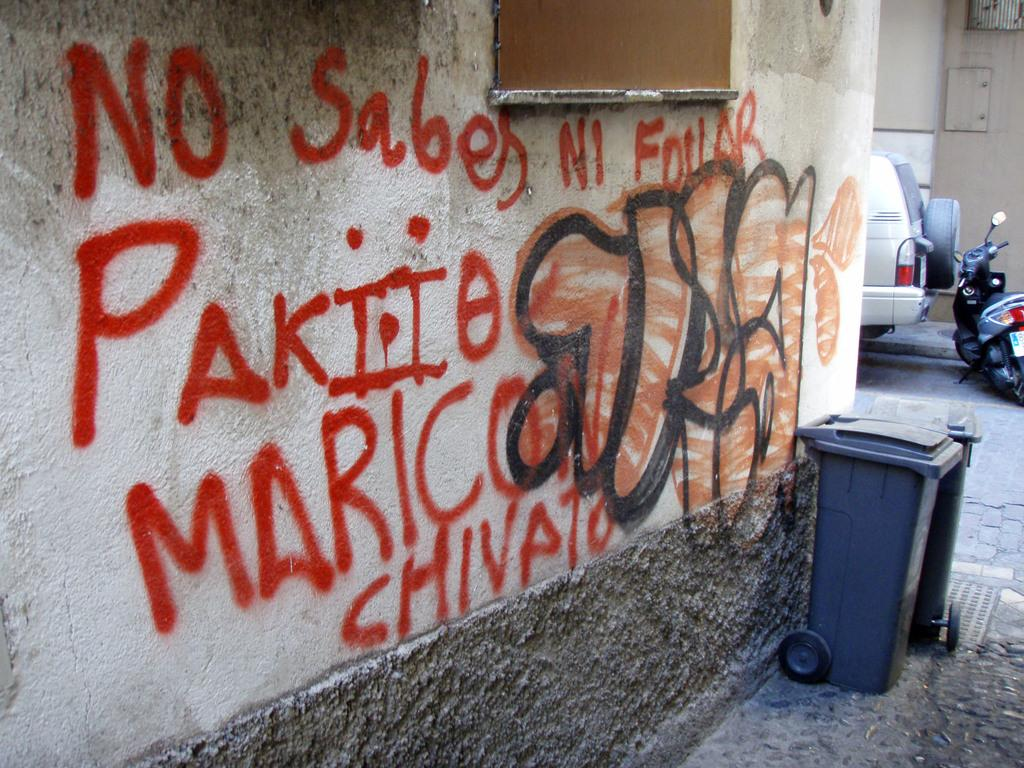<image>
Provide a brief description of the given image. A white plaster wall outside of a building has orange graffiti painted on in in Spanish. 